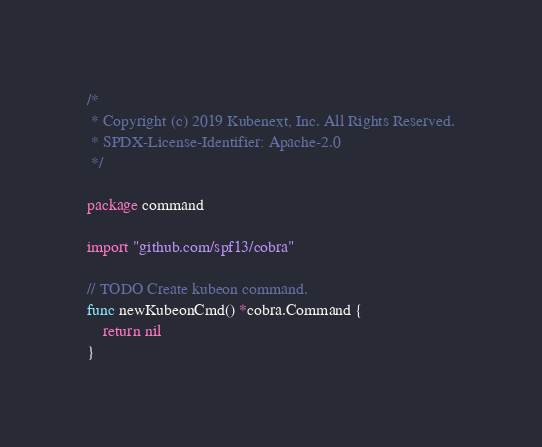Convert code to text. <code><loc_0><loc_0><loc_500><loc_500><_Go_>/*
 * Copyright (c) 2019 Kubenext, Inc. All Rights Reserved.
 * SPDX-License-Identifier: Apache-2.0
 */

package command

import "github.com/spf13/cobra"

// TODO Create kubeon command.
func newKubeonCmd() *cobra.Command {
	return nil
}
</code> 